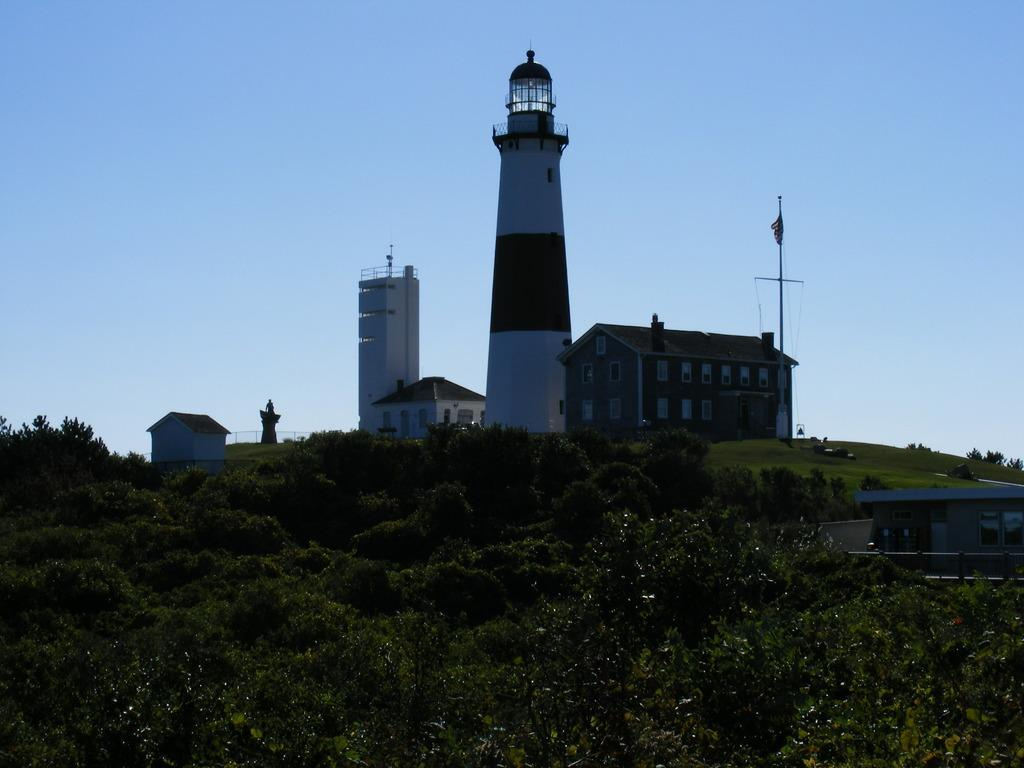What type of structures can be seen in the image? There are buildings and a lighthouse in the image. What is attached to a flag post in the image? There is a flag on a flag post in the image. What type of vegetation is present in the image? There are trees and bushes in the image. What part of the natural environment is visible in the image? The sky is visible in the image. Can you tell me how many ladybugs are crawling on the lighthouse in the image? There are no ladybugs in the image, let alone ladybugs. Who is the manager of the buildings in the image? The image does not provide information about the management of the buildings. 